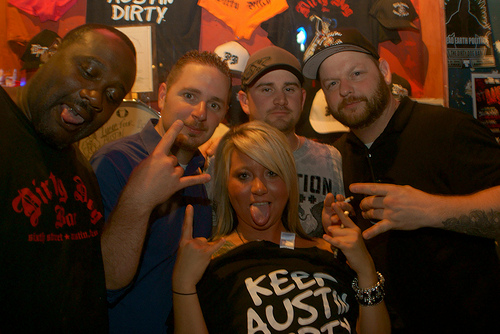<image>
Is there a man on the women? No. The man is not positioned on the women. They may be near each other, but the man is not supported by or resting on top of the women. Is the hat behind the man? Yes. From this viewpoint, the hat is positioned behind the man, with the man partially or fully occluding the hat. 